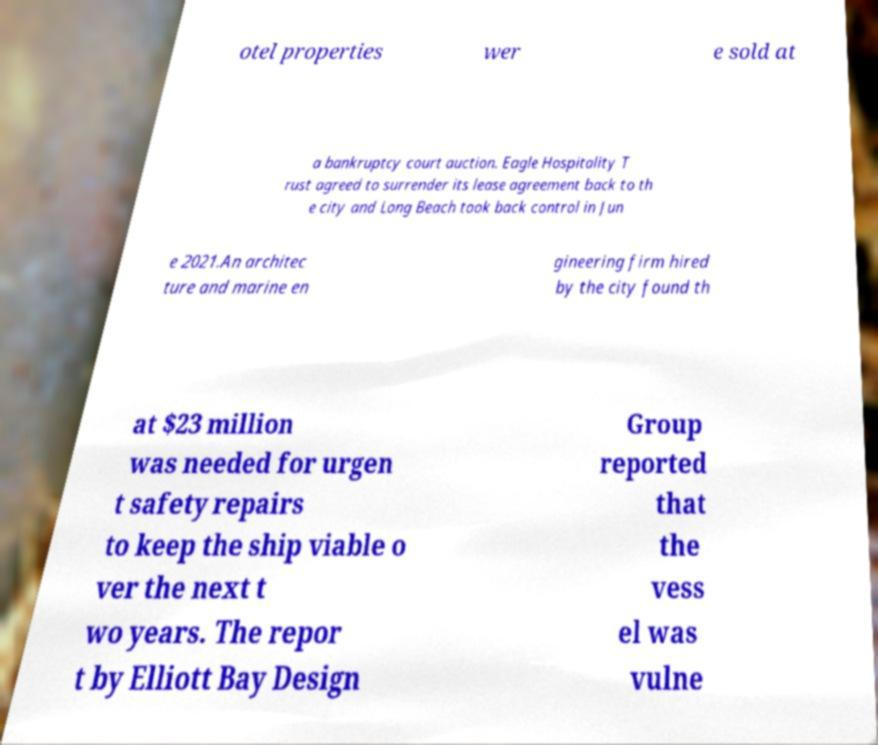Can you read and provide the text displayed in the image?This photo seems to have some interesting text. Can you extract and type it out for me? otel properties wer e sold at a bankruptcy court auction. Eagle Hospitality T rust agreed to surrender its lease agreement back to th e city and Long Beach took back control in Jun e 2021.An architec ture and marine en gineering firm hired by the city found th at $23 million was needed for urgen t safety repairs to keep the ship viable o ver the next t wo years. The repor t by Elliott Bay Design Group reported that the vess el was vulne 